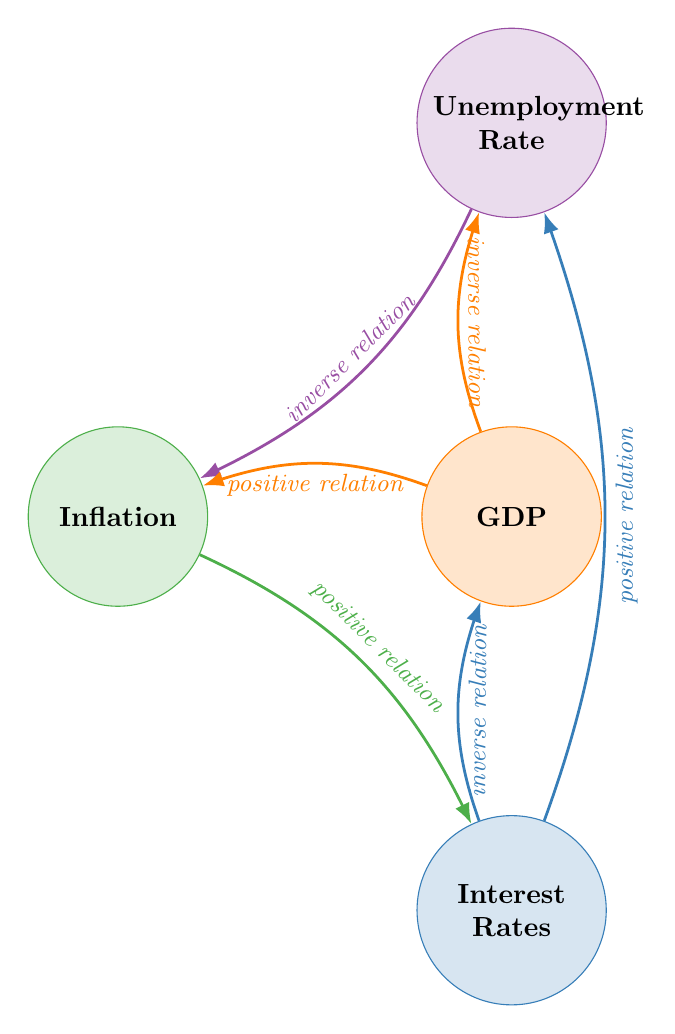What is the total number of nodes in the diagram? The diagram contains four nodes: GDP, Unemployment Rate, Inflation, and Interest Rates.
Answer: 4 What type of relationship exists between GDP and Unemployment Rate? The diagram specifies an "inverse relation" between GDP and Unemployment Rate, meaning when one increases, the other decreases.
Answer: inverse Which two indicators have a positive relationship? The diagram shows that both the GDP and Inflation indicators are related positively, indicating higher GDP can lead to higher inflation.
Answer: GDP and Inflation How does Interest Rates affect GDP? According to the diagram, the interaction described is an "inverse relation," meaning higher interest rates lead to lower GDP growth.
Answer: inverse What is the relationship between Unemployment Rate and Inflation? The diagram indicates an "inverse relation" between Unemployment Rate and Inflation, implying that as one decreases, the other tends to increase.
Answer: inverse If Inflation increases, what is likely to happen to Interest Rates? The diagram illustrates a "positive relation," meaning that an increase in Inflation usually leads to a rise in Interest Rates.
Answer: higher Which indicator is indicated as increasing when Interest Rates rise? The diagram shows a "positive relation" between Interest Rates and Unemployment Rate, suggesting that as Interest Rates rise, the Unemployment Rate tends to increase.
Answer: Unemployment Rate What color represents Inflation in the diagram? The diagram uses green (RGB: 77, 175, 74) to represent Inflation.
Answer: green How many total interactions are shown in the diagram? There are six interactions described between the four nodes in the diagram, including inverse and positive relationships.
Answer: 6 